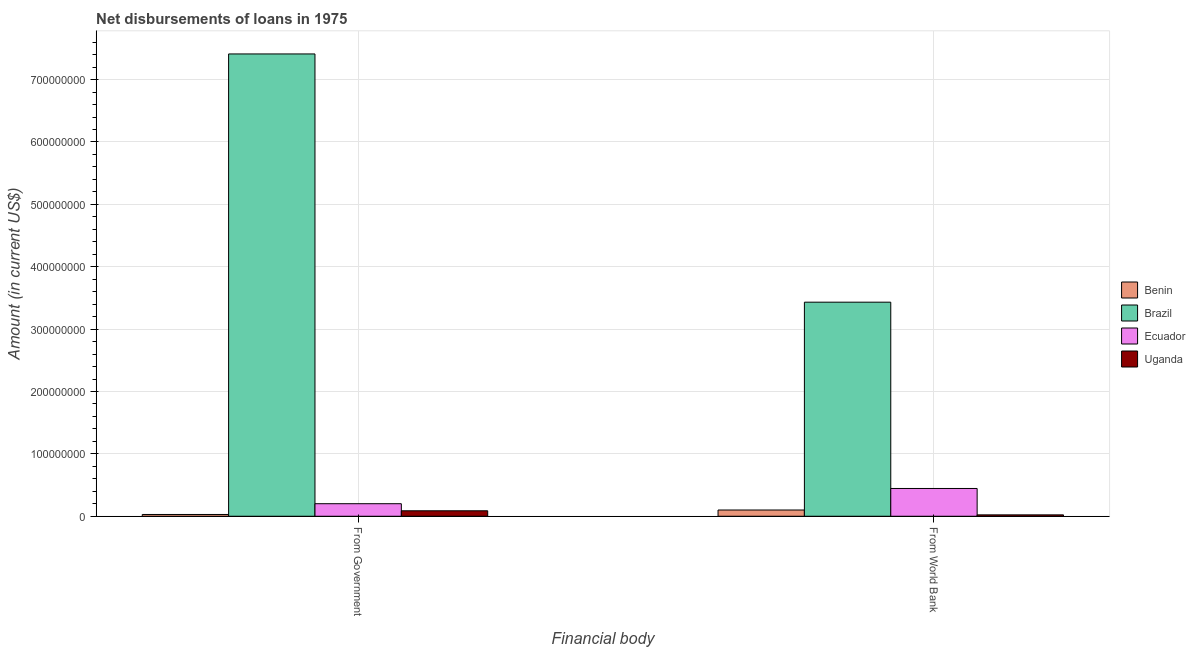Are the number of bars per tick equal to the number of legend labels?
Make the answer very short. Yes. How many bars are there on the 2nd tick from the left?
Your answer should be compact. 4. How many bars are there on the 2nd tick from the right?
Give a very brief answer. 4. What is the label of the 1st group of bars from the left?
Provide a succinct answer. From Government. What is the net disbursements of loan from government in Uganda?
Provide a short and direct response. 8.76e+06. Across all countries, what is the maximum net disbursements of loan from government?
Make the answer very short. 7.41e+08. Across all countries, what is the minimum net disbursements of loan from government?
Your response must be concise. 2.84e+06. In which country was the net disbursements of loan from government maximum?
Provide a short and direct response. Brazil. In which country was the net disbursements of loan from government minimum?
Your response must be concise. Benin. What is the total net disbursements of loan from world bank in the graph?
Give a very brief answer. 4.00e+08. What is the difference between the net disbursements of loan from world bank in Brazil and that in Uganda?
Provide a succinct answer. 3.41e+08. What is the difference between the net disbursements of loan from world bank in Benin and the net disbursements of loan from government in Ecuador?
Your answer should be compact. -1.01e+07. What is the average net disbursements of loan from world bank per country?
Provide a succinct answer. 1.00e+08. What is the difference between the net disbursements of loan from world bank and net disbursements of loan from government in Brazil?
Give a very brief answer. -3.98e+08. In how many countries, is the net disbursements of loan from government greater than 280000000 US$?
Make the answer very short. 1. What is the ratio of the net disbursements of loan from world bank in Brazil to that in Benin?
Make the answer very short. 34.25. Is the net disbursements of loan from world bank in Ecuador less than that in Uganda?
Ensure brevity in your answer.  No. What does the 2nd bar from the left in From Government represents?
Ensure brevity in your answer.  Brazil. What does the 2nd bar from the right in From World Bank represents?
Your answer should be very brief. Ecuador. How many bars are there?
Offer a terse response. 8. Are all the bars in the graph horizontal?
Ensure brevity in your answer.  No. Does the graph contain grids?
Offer a terse response. Yes. How are the legend labels stacked?
Ensure brevity in your answer.  Vertical. What is the title of the graph?
Provide a short and direct response. Net disbursements of loans in 1975. What is the label or title of the X-axis?
Offer a very short reply. Financial body. What is the label or title of the Y-axis?
Offer a very short reply. Amount (in current US$). What is the Amount (in current US$) of Benin in From Government?
Your response must be concise. 2.84e+06. What is the Amount (in current US$) in Brazil in From Government?
Provide a short and direct response. 7.41e+08. What is the Amount (in current US$) of Ecuador in From Government?
Offer a very short reply. 2.01e+07. What is the Amount (in current US$) in Uganda in From Government?
Keep it short and to the point. 8.76e+06. What is the Amount (in current US$) of Benin in From World Bank?
Offer a very short reply. 1.00e+07. What is the Amount (in current US$) in Brazil in From World Bank?
Provide a short and direct response. 3.43e+08. What is the Amount (in current US$) in Ecuador in From World Bank?
Ensure brevity in your answer.  4.45e+07. What is the Amount (in current US$) of Uganda in From World Bank?
Offer a terse response. 2.22e+06. Across all Financial body, what is the maximum Amount (in current US$) in Benin?
Your answer should be very brief. 1.00e+07. Across all Financial body, what is the maximum Amount (in current US$) of Brazil?
Your answer should be very brief. 7.41e+08. Across all Financial body, what is the maximum Amount (in current US$) in Ecuador?
Your answer should be compact. 4.45e+07. Across all Financial body, what is the maximum Amount (in current US$) of Uganda?
Offer a terse response. 8.76e+06. Across all Financial body, what is the minimum Amount (in current US$) of Benin?
Offer a terse response. 2.84e+06. Across all Financial body, what is the minimum Amount (in current US$) of Brazil?
Give a very brief answer. 3.43e+08. Across all Financial body, what is the minimum Amount (in current US$) of Ecuador?
Keep it short and to the point. 2.01e+07. Across all Financial body, what is the minimum Amount (in current US$) in Uganda?
Ensure brevity in your answer.  2.22e+06. What is the total Amount (in current US$) of Benin in the graph?
Make the answer very short. 1.29e+07. What is the total Amount (in current US$) of Brazil in the graph?
Provide a succinct answer. 1.08e+09. What is the total Amount (in current US$) of Ecuador in the graph?
Ensure brevity in your answer.  6.47e+07. What is the total Amount (in current US$) in Uganda in the graph?
Keep it short and to the point. 1.10e+07. What is the difference between the Amount (in current US$) of Benin in From Government and that in From World Bank?
Give a very brief answer. -7.18e+06. What is the difference between the Amount (in current US$) of Brazil in From Government and that in From World Bank?
Offer a terse response. 3.98e+08. What is the difference between the Amount (in current US$) of Ecuador in From Government and that in From World Bank?
Give a very brief answer. -2.44e+07. What is the difference between the Amount (in current US$) in Uganda in From Government and that in From World Bank?
Your response must be concise. 6.54e+06. What is the difference between the Amount (in current US$) in Benin in From Government and the Amount (in current US$) in Brazil in From World Bank?
Provide a succinct answer. -3.40e+08. What is the difference between the Amount (in current US$) in Benin in From Government and the Amount (in current US$) in Ecuador in From World Bank?
Provide a short and direct response. -4.17e+07. What is the difference between the Amount (in current US$) of Benin in From Government and the Amount (in current US$) of Uganda in From World Bank?
Provide a succinct answer. 6.18e+05. What is the difference between the Amount (in current US$) in Brazil in From Government and the Amount (in current US$) in Ecuador in From World Bank?
Your response must be concise. 6.97e+08. What is the difference between the Amount (in current US$) of Brazil in From Government and the Amount (in current US$) of Uganda in From World Bank?
Your answer should be very brief. 7.39e+08. What is the difference between the Amount (in current US$) in Ecuador in From Government and the Amount (in current US$) in Uganda in From World Bank?
Keep it short and to the point. 1.79e+07. What is the average Amount (in current US$) of Benin per Financial body?
Provide a succinct answer. 6.43e+06. What is the average Amount (in current US$) in Brazil per Financial body?
Provide a short and direct response. 5.42e+08. What is the average Amount (in current US$) in Ecuador per Financial body?
Your response must be concise. 3.23e+07. What is the average Amount (in current US$) of Uganda per Financial body?
Your answer should be very brief. 5.49e+06. What is the difference between the Amount (in current US$) in Benin and Amount (in current US$) in Brazil in From Government?
Your answer should be very brief. -7.38e+08. What is the difference between the Amount (in current US$) of Benin and Amount (in current US$) of Ecuador in From Government?
Ensure brevity in your answer.  -1.73e+07. What is the difference between the Amount (in current US$) in Benin and Amount (in current US$) in Uganda in From Government?
Your answer should be very brief. -5.92e+06. What is the difference between the Amount (in current US$) of Brazil and Amount (in current US$) of Ecuador in From Government?
Provide a short and direct response. 7.21e+08. What is the difference between the Amount (in current US$) in Brazil and Amount (in current US$) in Uganda in From Government?
Ensure brevity in your answer.  7.32e+08. What is the difference between the Amount (in current US$) in Ecuador and Amount (in current US$) in Uganda in From Government?
Offer a terse response. 1.14e+07. What is the difference between the Amount (in current US$) of Benin and Amount (in current US$) of Brazil in From World Bank?
Ensure brevity in your answer.  -3.33e+08. What is the difference between the Amount (in current US$) in Benin and Amount (in current US$) in Ecuador in From World Bank?
Provide a succinct answer. -3.45e+07. What is the difference between the Amount (in current US$) of Benin and Amount (in current US$) of Uganda in From World Bank?
Offer a very short reply. 7.80e+06. What is the difference between the Amount (in current US$) in Brazil and Amount (in current US$) in Ecuador in From World Bank?
Make the answer very short. 2.99e+08. What is the difference between the Amount (in current US$) of Brazil and Amount (in current US$) of Uganda in From World Bank?
Your answer should be very brief. 3.41e+08. What is the difference between the Amount (in current US$) in Ecuador and Amount (in current US$) in Uganda in From World Bank?
Provide a succinct answer. 4.23e+07. What is the ratio of the Amount (in current US$) in Benin in From Government to that in From World Bank?
Offer a very short reply. 0.28. What is the ratio of the Amount (in current US$) in Brazil in From Government to that in From World Bank?
Keep it short and to the point. 2.16. What is the ratio of the Amount (in current US$) of Ecuador in From Government to that in From World Bank?
Offer a terse response. 0.45. What is the ratio of the Amount (in current US$) in Uganda in From Government to that in From World Bank?
Make the answer very short. 3.95. What is the difference between the highest and the second highest Amount (in current US$) in Benin?
Your response must be concise. 7.18e+06. What is the difference between the highest and the second highest Amount (in current US$) in Brazil?
Your answer should be very brief. 3.98e+08. What is the difference between the highest and the second highest Amount (in current US$) of Ecuador?
Your answer should be compact. 2.44e+07. What is the difference between the highest and the second highest Amount (in current US$) in Uganda?
Keep it short and to the point. 6.54e+06. What is the difference between the highest and the lowest Amount (in current US$) in Benin?
Offer a terse response. 7.18e+06. What is the difference between the highest and the lowest Amount (in current US$) in Brazil?
Your answer should be compact. 3.98e+08. What is the difference between the highest and the lowest Amount (in current US$) of Ecuador?
Make the answer very short. 2.44e+07. What is the difference between the highest and the lowest Amount (in current US$) in Uganda?
Offer a very short reply. 6.54e+06. 